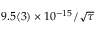Convert formula to latex. <formula><loc_0><loc_0><loc_500><loc_500>9 . 5 ( 3 ) \times 1 0 ^ { - 1 5 } / \sqrt { \tau }</formula> 